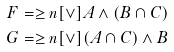Convert formula to latex. <formula><loc_0><loc_0><loc_500><loc_500>F & = \geq n [ \vee ] { A \wedge ( B \cap C ) } \\ G & = \geq n [ \vee ] { ( A \cap C ) \wedge B }</formula> 